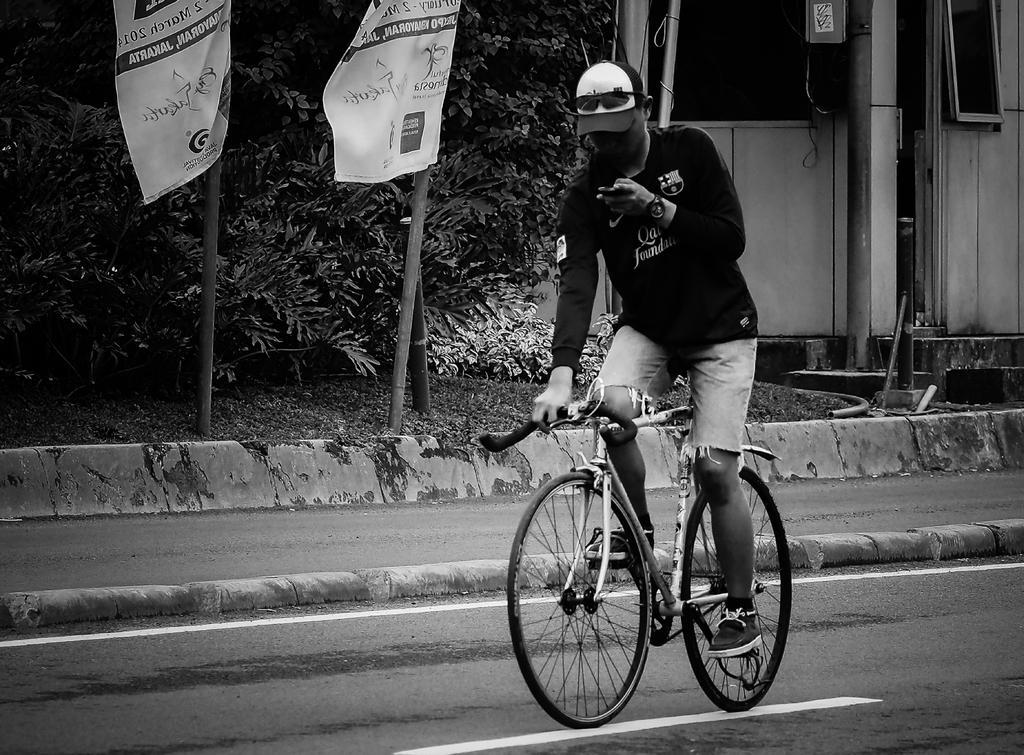Describe this image in one or two sentences. In this picture we can see a man wore helmet, black color T-Shirt riding bicycle on road and beside to the road we have foot path and beside to this foot path we have poles with flag, trees and some building with metals. 